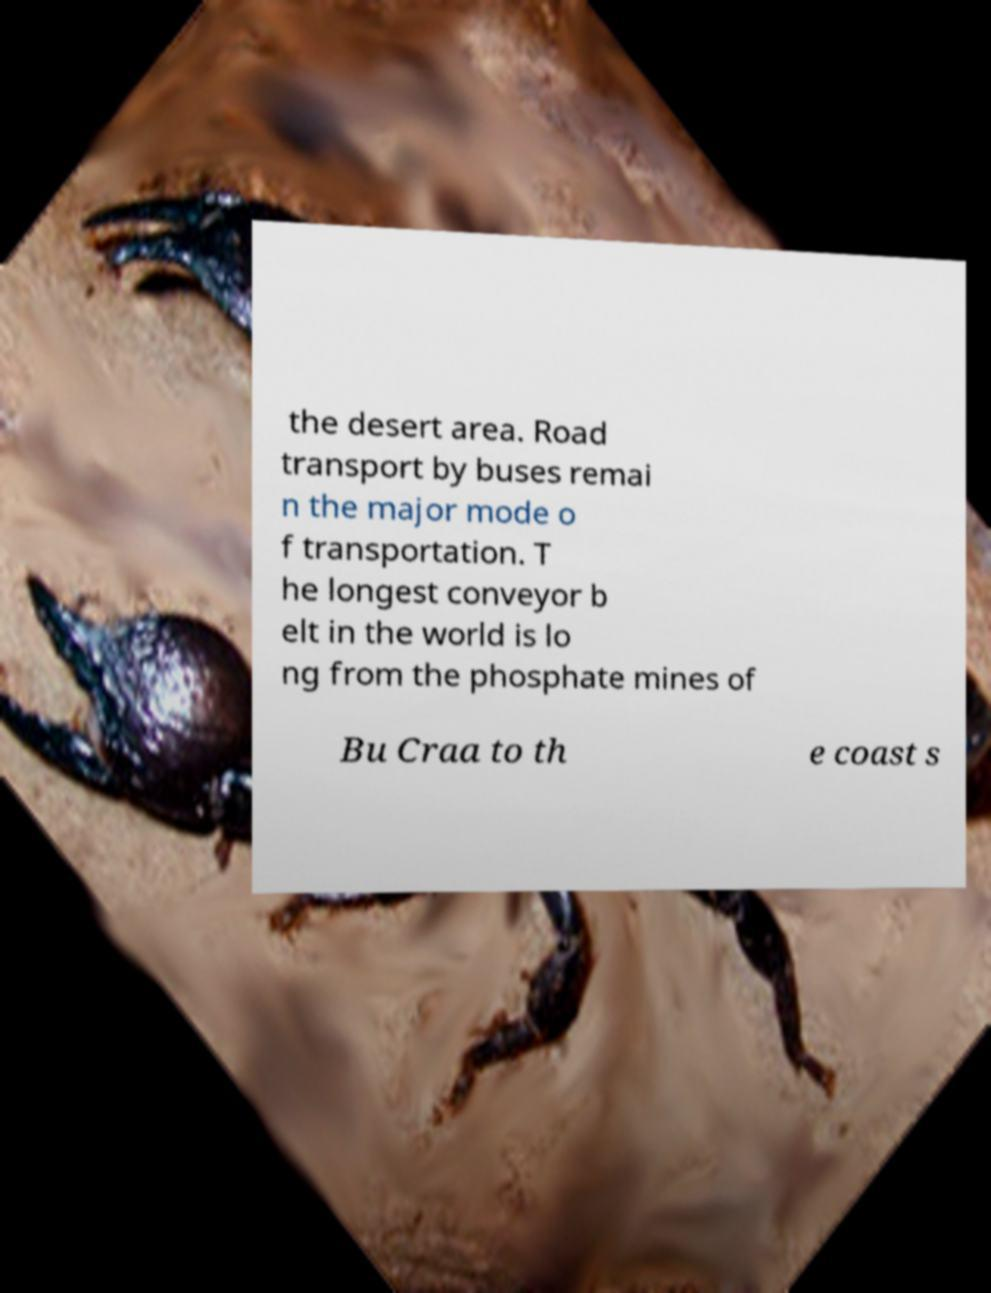Please read and relay the text visible in this image. What does it say? the desert area. Road transport by buses remai n the major mode o f transportation. T he longest conveyor b elt in the world is lo ng from the phosphate mines of Bu Craa to th e coast s 